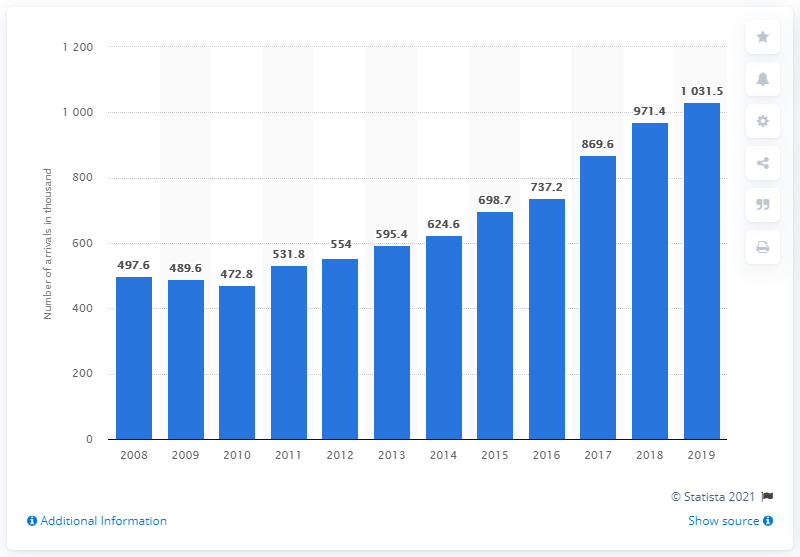Specify some key components in this picture. Since the year 2010, the number of tourist arrivals at accommodation establishments in North Macedonia has been increasing. 